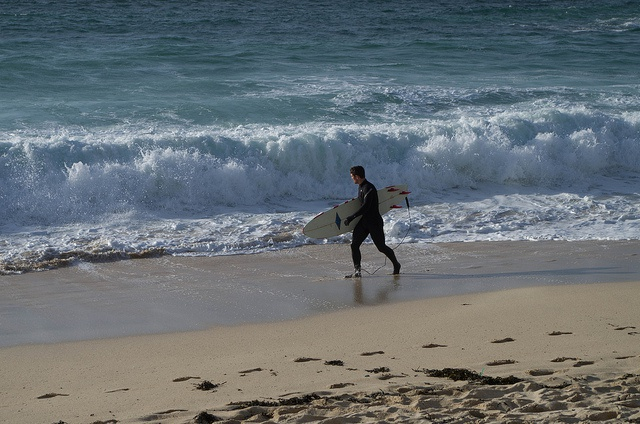Describe the objects in this image and their specific colors. I can see people in darkblue, black, gray, darkgray, and maroon tones and surfboard in darkblue, gray, black, and maroon tones in this image. 